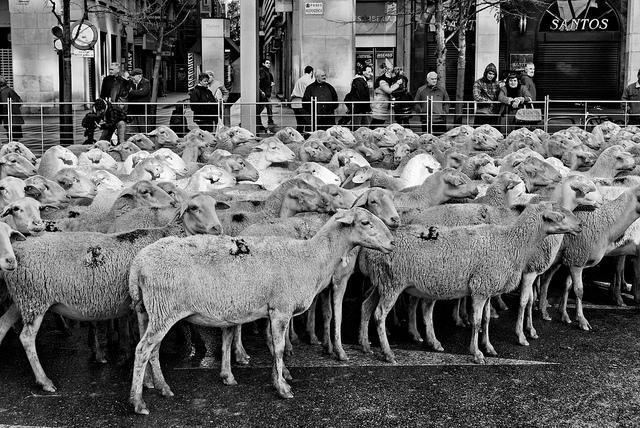How many people can be seen?
Give a very brief answer. 15. How many sheep are there?
Give a very brief answer. 7. 